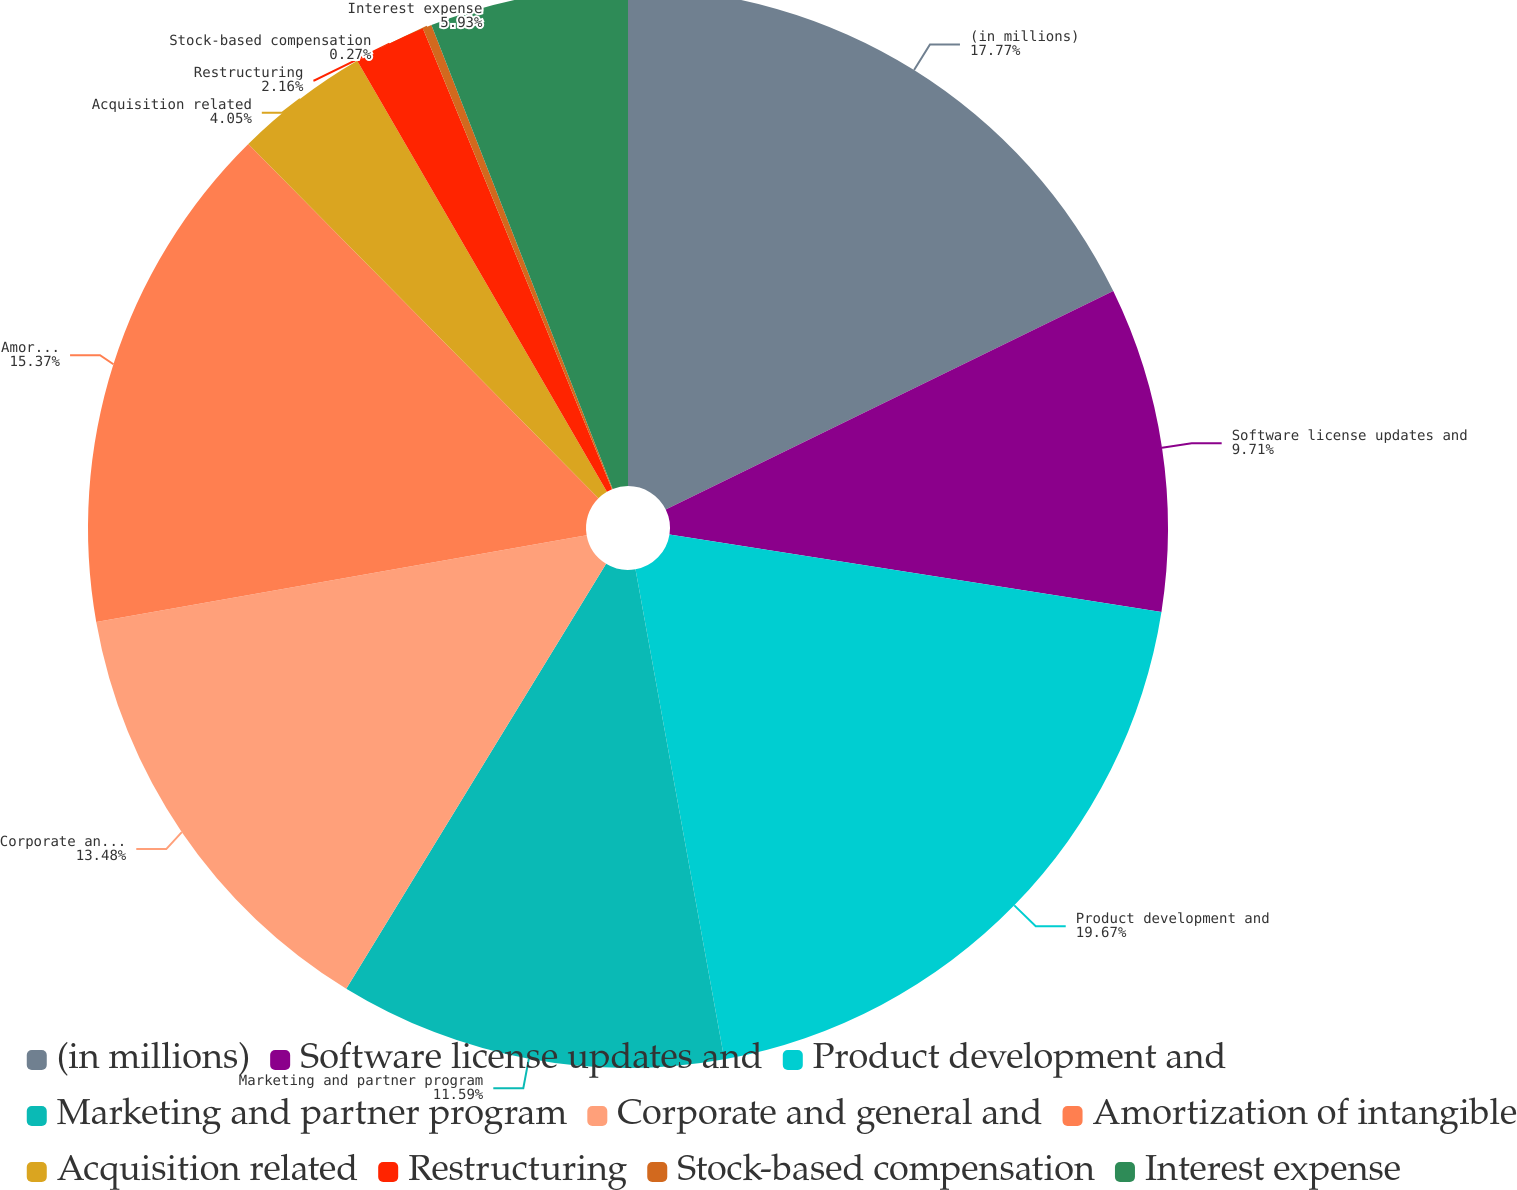Convert chart. <chart><loc_0><loc_0><loc_500><loc_500><pie_chart><fcel>(in millions)<fcel>Software license updates and<fcel>Product development and<fcel>Marketing and partner program<fcel>Corporate and general and<fcel>Amortization of intangible<fcel>Acquisition related<fcel>Restructuring<fcel>Stock-based compensation<fcel>Interest expense<nl><fcel>17.77%<fcel>9.71%<fcel>19.66%<fcel>11.59%<fcel>13.48%<fcel>15.37%<fcel>4.05%<fcel>2.16%<fcel>0.27%<fcel>5.93%<nl></chart> 